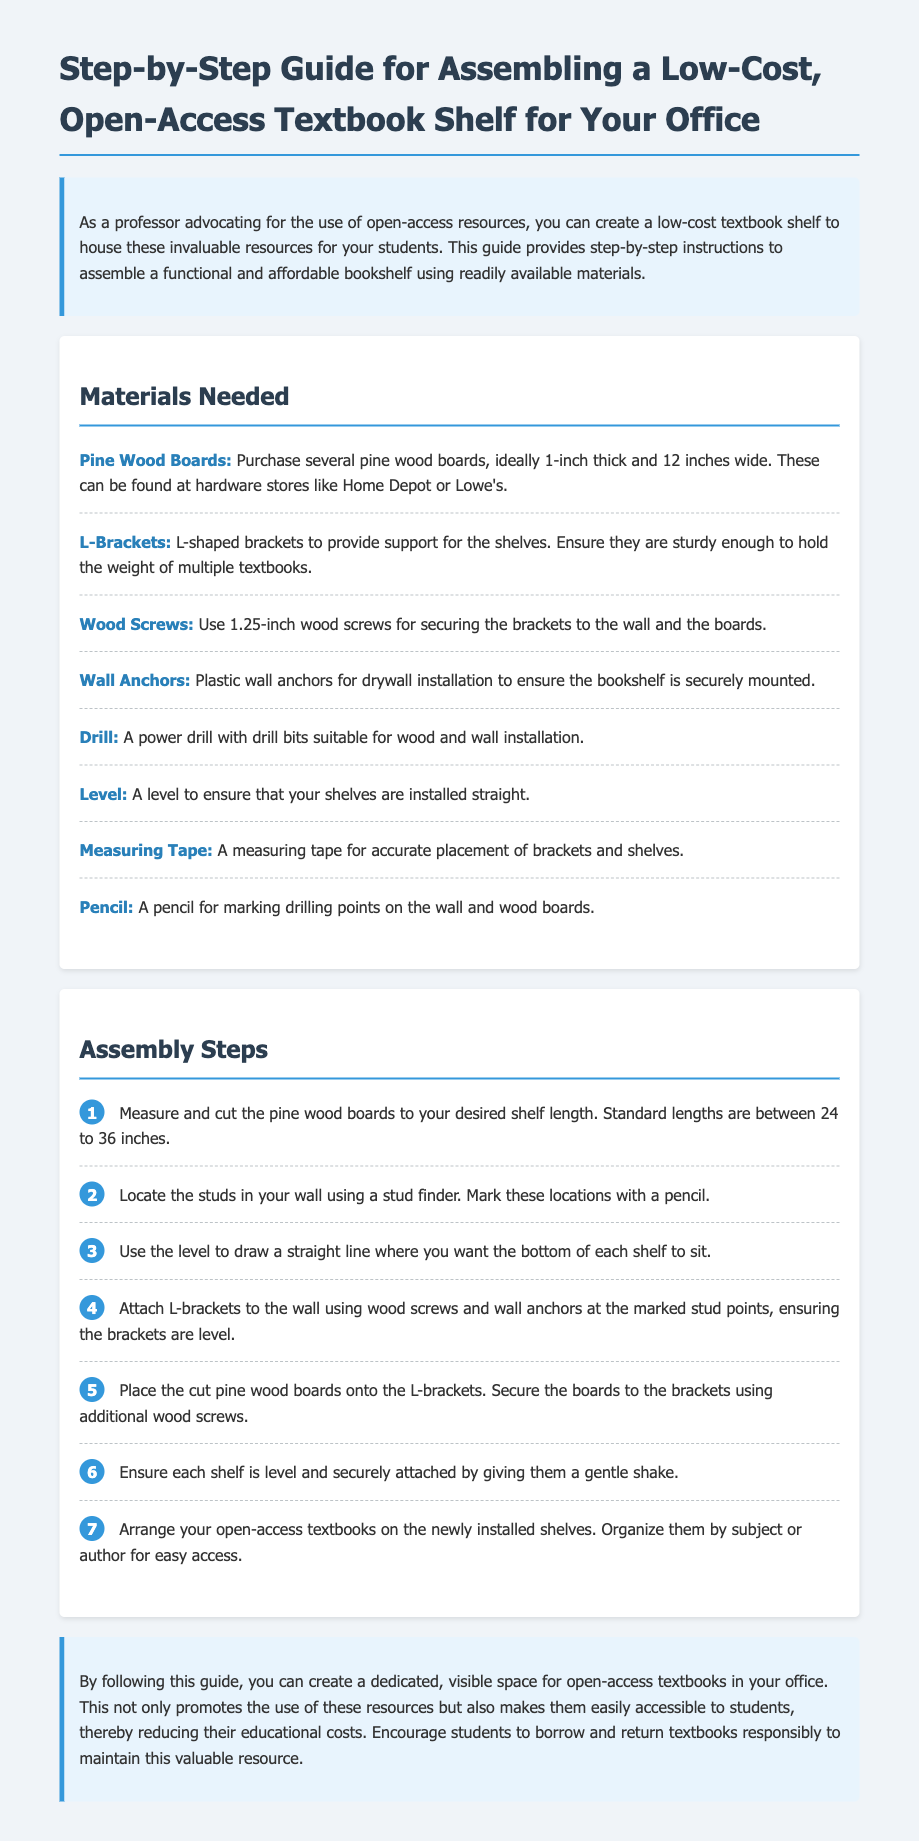What materials are needed for the bookshelf? The materials listed in the document include pine wood boards, L-brackets, wood screws, wall anchors, a drill, a level, measuring tape, and a pencil.
Answer: Pine Wood Boards, L-Brackets, Wood Screws, Wall Anchors, Drill, Level, Measuring Tape, Pencil What thickness should the pine wood boards be? The thickness specified in the document for the pine wood boards is 1 inch.
Answer: 1 inch How many assembly steps are there in total? The document lists seven distinct steps to compile, which are numbered sequentially from 1 to 7.
Answer: 7 What should be marked on the wall before attaching the L-brackets? The document instructs to mark the locations of the studs on the wall using a pencil.
Answer: stud locations What is the purpose of the level in the assembly process? The level's role is to ensure that the brackets and shelves are installed straight, which is critical for stability.
Answer: ensuring straight installation What is the final step in the assembly of the bookshelf? The last step mentioned in the assembly instructions is to arrange open-access textbooks on the installed shelves.
Answer: Arrange textbooks What are the ideal lengths of the pine wood boards for the shelves? The document suggests that standard lengths for the pine wood boards are between 24 to 36 inches.
Answer: 24 to 36 inches What can be borrowed from the newly installed shelves? The shelves are designated for housing open-access textbooks that students can borrow.
Answer: open-access textbooks 